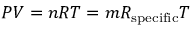Convert formula to latex. <formula><loc_0><loc_0><loc_500><loc_500>P V = n R T = m R _ { s p e c i f i c } T</formula> 